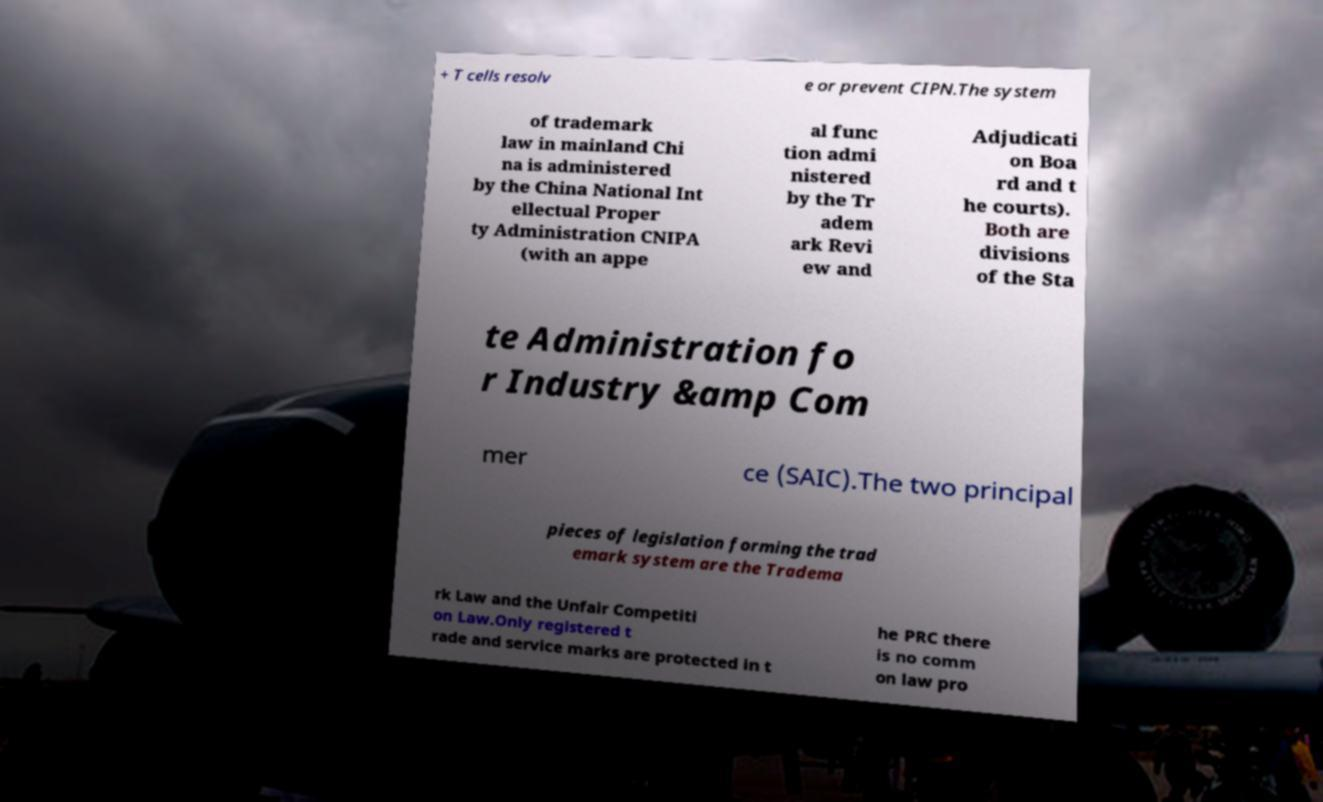For documentation purposes, I need the text within this image transcribed. Could you provide that? + T cells resolv e or prevent CIPN.The system of trademark law in mainland Chi na is administered by the China National Int ellectual Proper ty Administration CNIPA (with an appe al func tion admi nistered by the Tr adem ark Revi ew and Adjudicati on Boa rd and t he courts). Both are divisions of the Sta te Administration fo r Industry &amp Com mer ce (SAIC).The two principal pieces of legislation forming the trad emark system are the Tradema rk Law and the Unfair Competiti on Law.Only registered t rade and service marks are protected in t he PRC there is no comm on law pro 